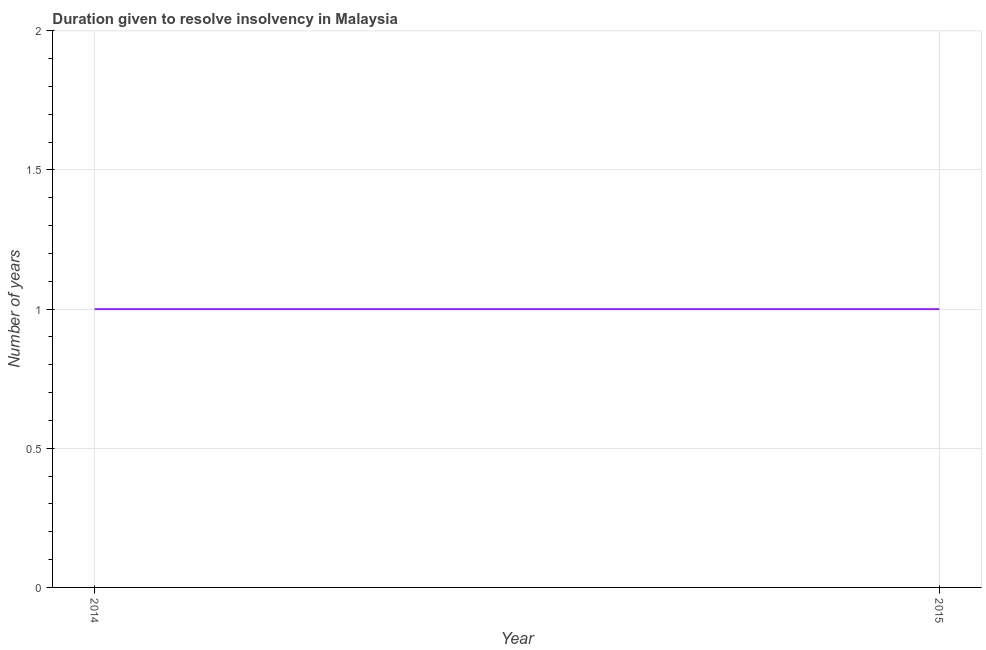What is the number of years to resolve insolvency in 2014?
Your answer should be compact. 1. Across all years, what is the maximum number of years to resolve insolvency?
Your answer should be compact. 1. Across all years, what is the minimum number of years to resolve insolvency?
Your response must be concise. 1. In which year was the number of years to resolve insolvency maximum?
Give a very brief answer. 2014. What is the sum of the number of years to resolve insolvency?
Provide a succinct answer. 2. What is the difference between the number of years to resolve insolvency in 2014 and 2015?
Your answer should be very brief. 0. What is the median number of years to resolve insolvency?
Provide a succinct answer. 1. In how many years, is the number of years to resolve insolvency greater than 1.1 ?
Give a very brief answer. 0. What is the ratio of the number of years to resolve insolvency in 2014 to that in 2015?
Give a very brief answer. 1. Is the number of years to resolve insolvency in 2014 less than that in 2015?
Your answer should be compact. No. In how many years, is the number of years to resolve insolvency greater than the average number of years to resolve insolvency taken over all years?
Provide a succinct answer. 0. How many lines are there?
Make the answer very short. 1. How many years are there in the graph?
Your response must be concise. 2. Are the values on the major ticks of Y-axis written in scientific E-notation?
Your answer should be very brief. No. Does the graph contain any zero values?
Offer a terse response. No. What is the title of the graph?
Make the answer very short. Duration given to resolve insolvency in Malaysia. What is the label or title of the Y-axis?
Offer a terse response. Number of years. 